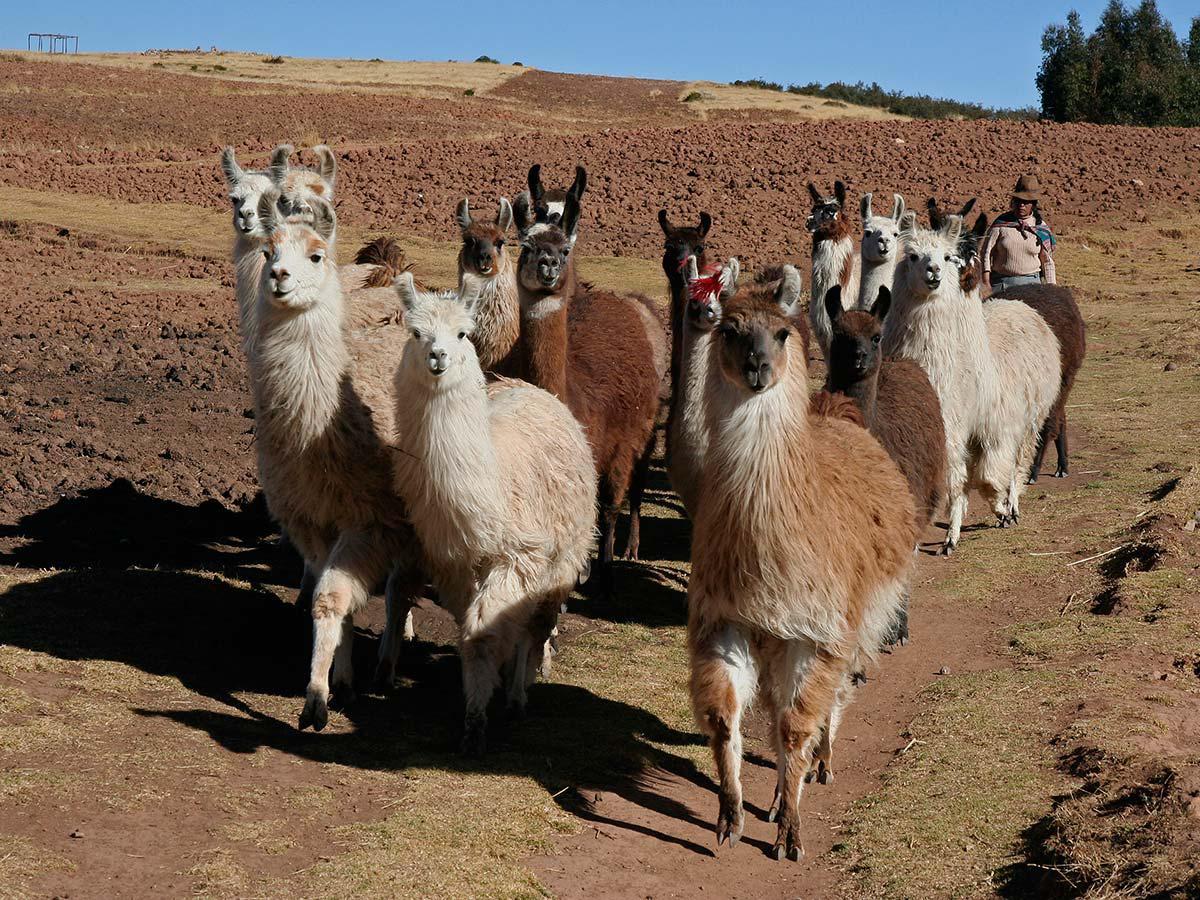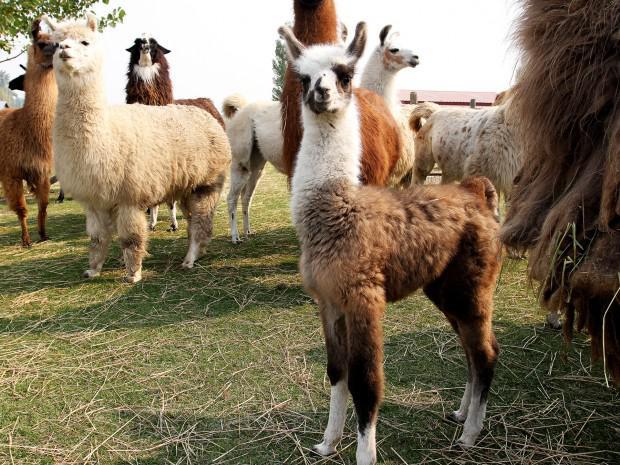The first image is the image on the left, the second image is the image on the right. Analyze the images presented: Is the assertion "One image shows at least ten llamas standing in place with their heads upright and angled rightward." valid? Answer yes or no. No. 